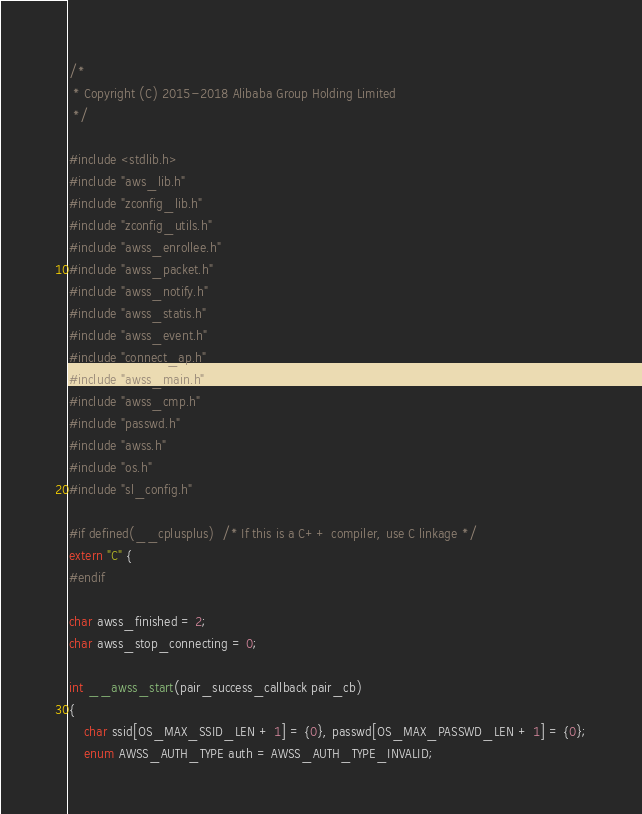<code> <loc_0><loc_0><loc_500><loc_500><_C_>/*
 * Copyright (C) 2015-2018 Alibaba Group Holding Limited
 */

#include <stdlib.h>
#include "aws_lib.h"
#include "zconfig_lib.h"
#include "zconfig_utils.h"
#include "awss_enrollee.h"
#include "awss_packet.h"
#include "awss_notify.h"
#include "awss_statis.h"
#include "awss_event.h"
#include "connect_ap.h"
#include "awss_main.h"
#include "awss_cmp.h"
#include "passwd.h"
#include "awss.h"
#include "os.h"
#include "sl_config.h"

#if defined(__cplusplus)  /* If this is a C++ compiler, use C linkage */
extern "C" {
#endif

char awss_finished = 2;
char awss_stop_connecting = 0;

int __awss_start(pair_success_callback pair_cb)
{
    char ssid[OS_MAX_SSID_LEN + 1] = {0}, passwd[OS_MAX_PASSWD_LEN + 1] = {0};
    enum AWSS_AUTH_TYPE auth = AWSS_AUTH_TYPE_INVALID;</code> 